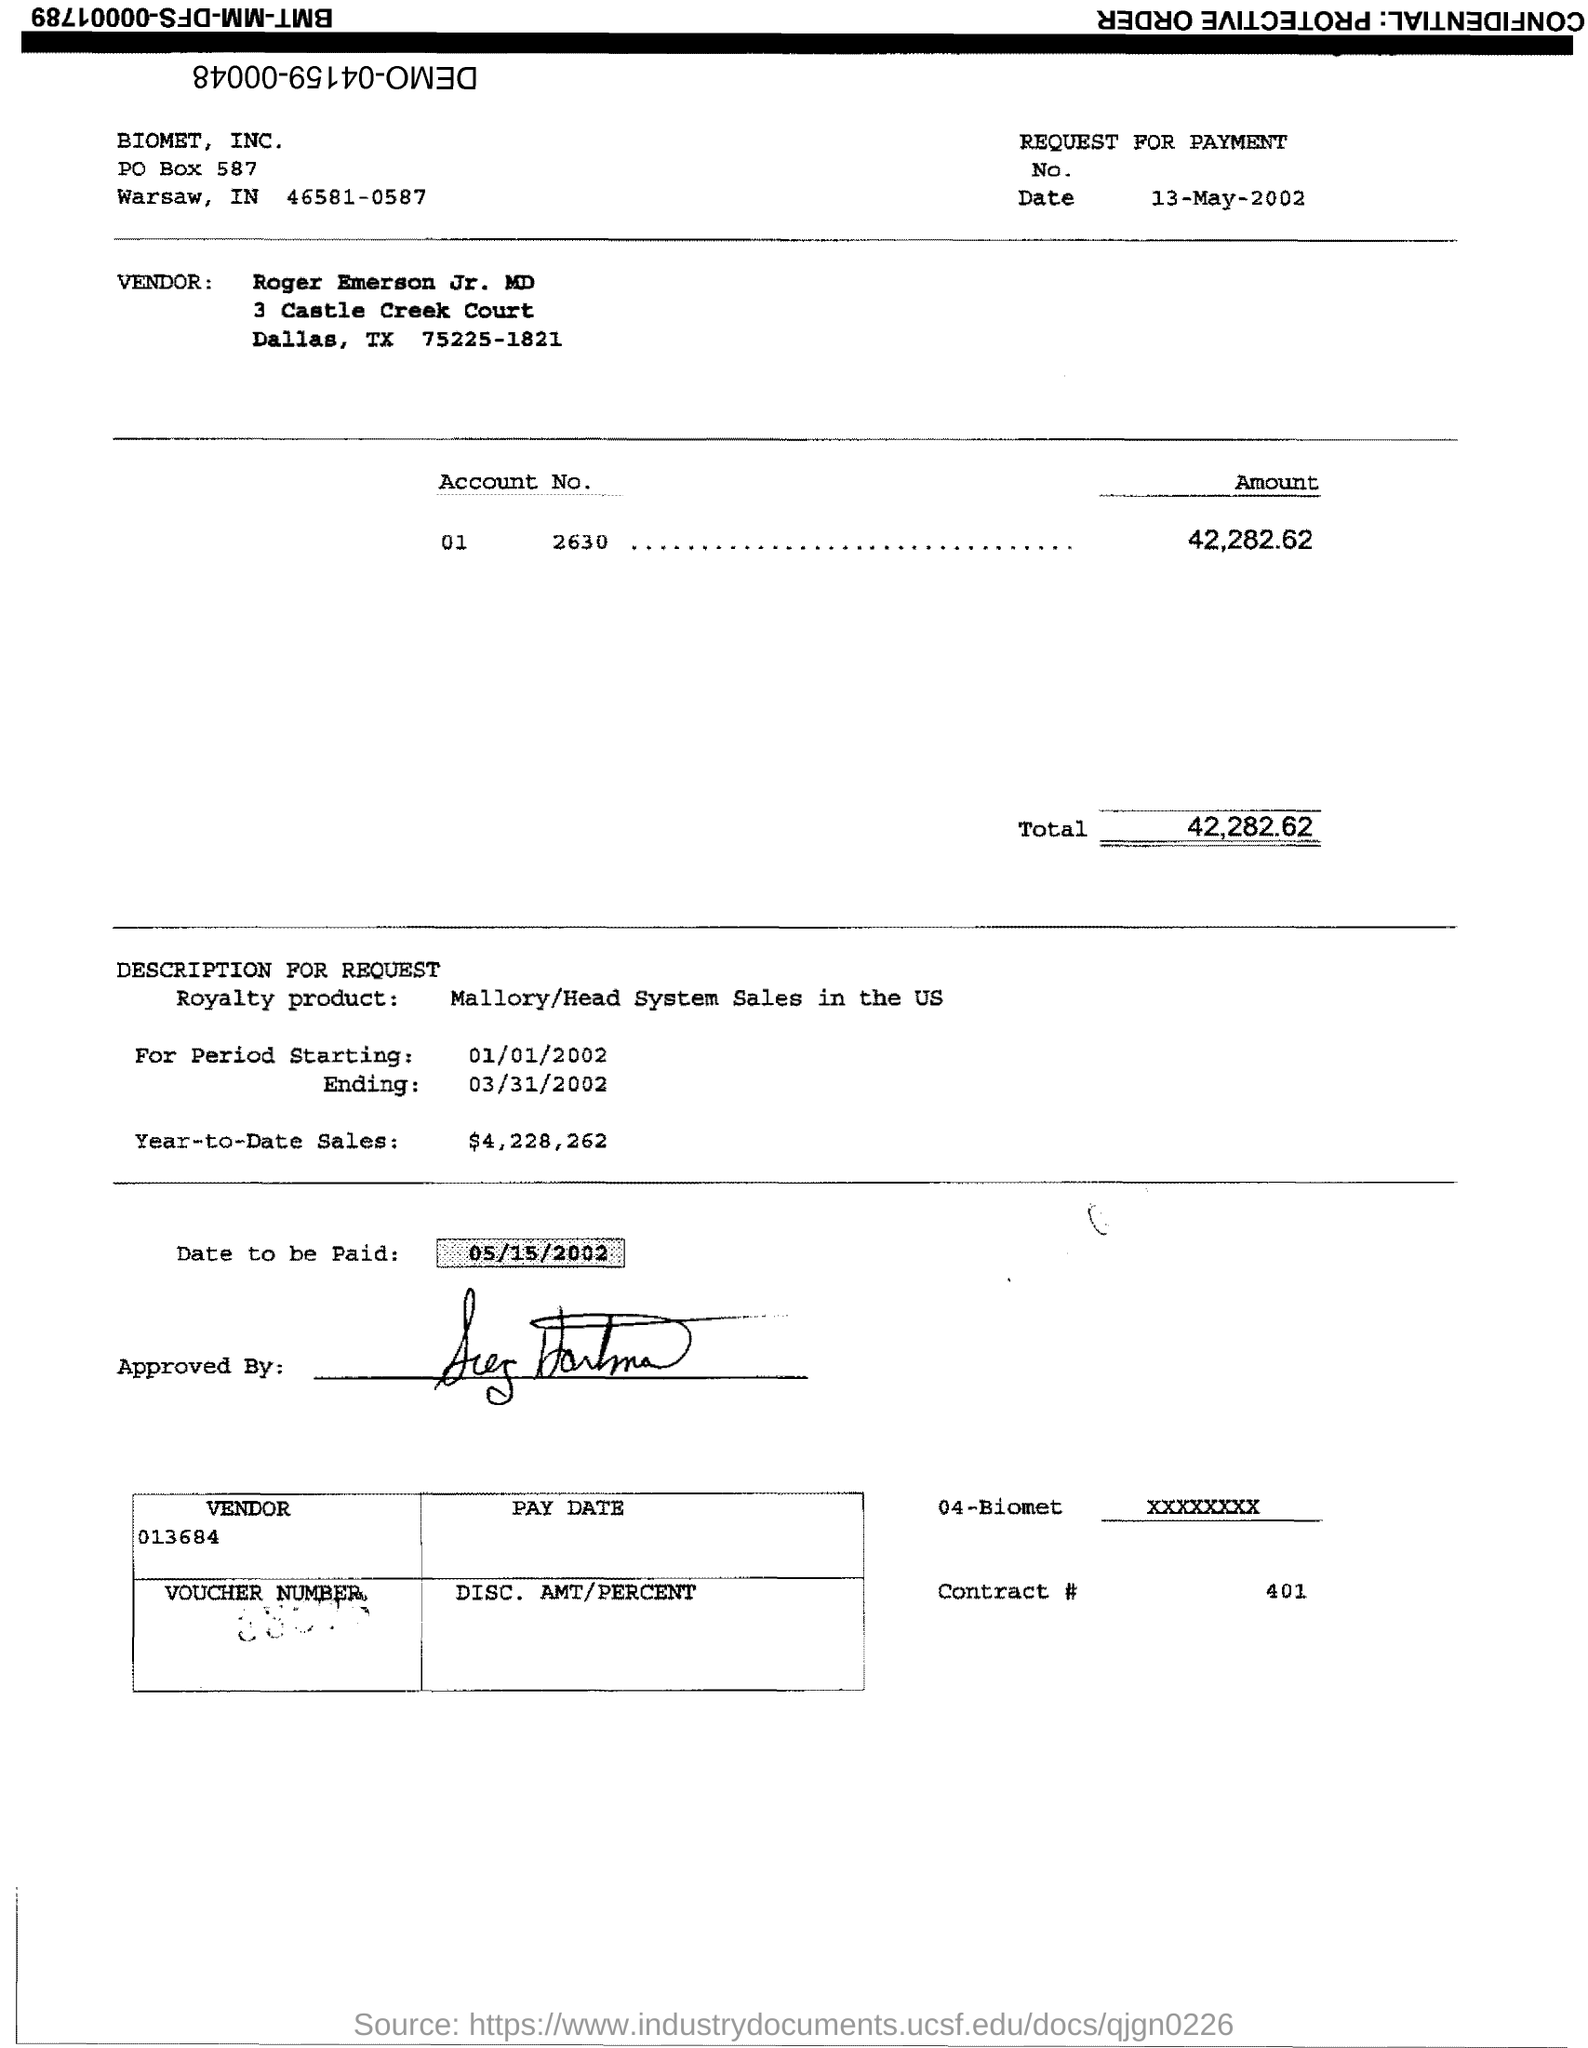What is the Total?
 42,282.62 